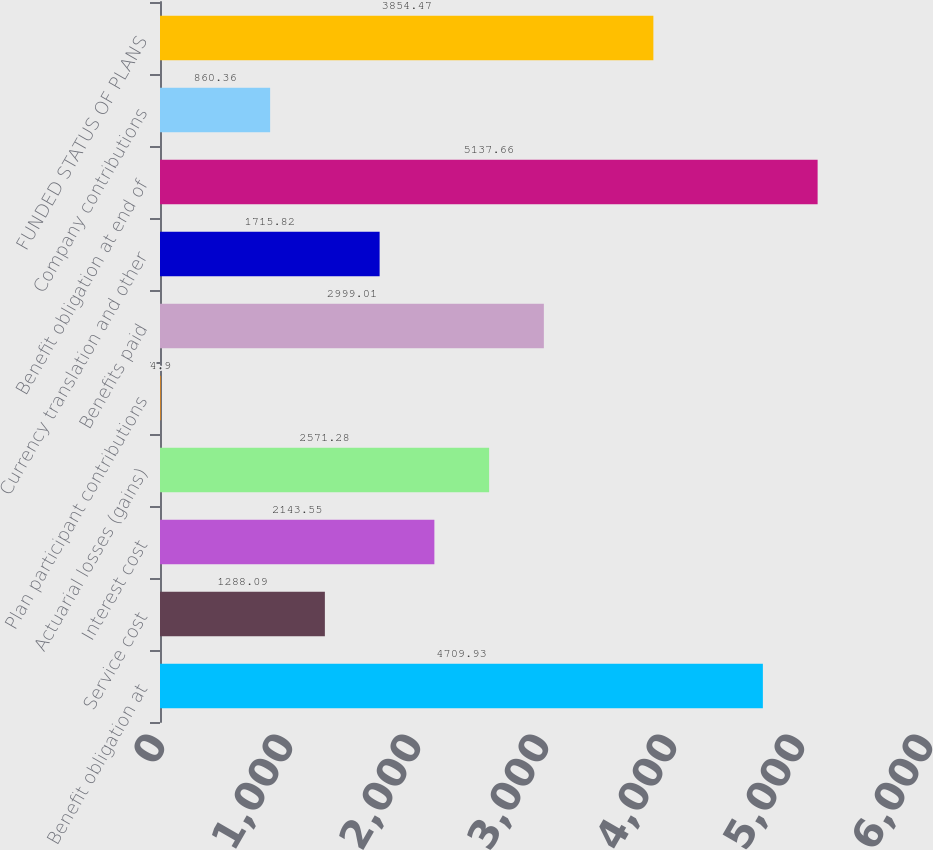Convert chart. <chart><loc_0><loc_0><loc_500><loc_500><bar_chart><fcel>Benefit obligation at<fcel>Service cost<fcel>Interest cost<fcel>Actuarial losses (gains)<fcel>Plan participant contributions<fcel>Benefits paid<fcel>Currency translation and other<fcel>Benefit obligation at end of<fcel>Company contributions<fcel>FUNDED STATUS OF PLANS<nl><fcel>4709.93<fcel>1288.09<fcel>2143.55<fcel>2571.28<fcel>4.9<fcel>2999.01<fcel>1715.82<fcel>5137.66<fcel>860.36<fcel>3854.47<nl></chart> 